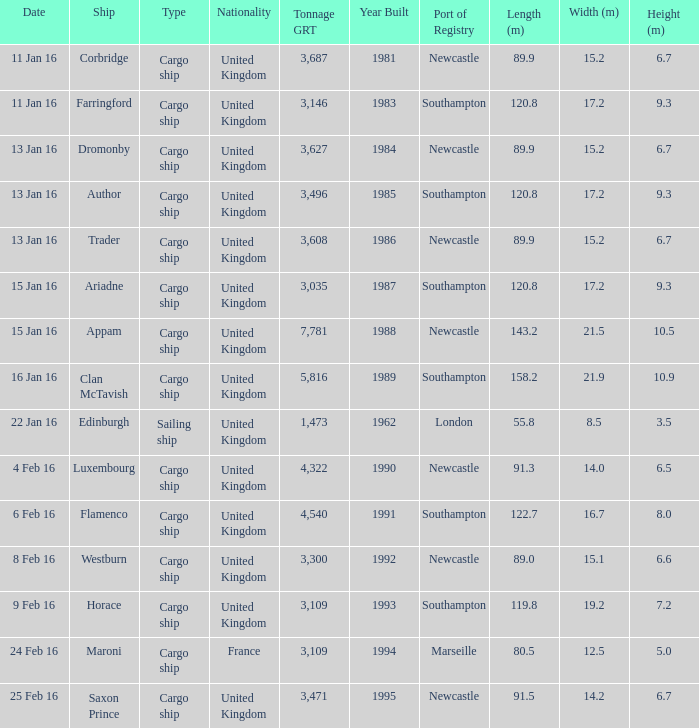Give me the full table as a dictionary. {'header': ['Date', 'Ship', 'Type', 'Nationality', 'Tonnage GRT', 'Year Built', 'Port of Registry', 'Length (m)', 'Width (m)', 'Height (m)'], 'rows': [['11 Jan 16', 'Corbridge', 'Cargo ship', 'United Kingdom', '3,687', '1981', 'Newcastle', '89.9', '15.2', '6.7'], ['11 Jan 16', 'Farringford', 'Cargo ship', 'United Kingdom', '3,146', '1983', 'Southampton', '120.8', '17.2', '9.3'], ['13 Jan 16', 'Dromonby', 'Cargo ship', 'United Kingdom', '3,627', '1984', 'Newcastle', '89.9', '15.2', '6.7'], ['13 Jan 16', 'Author', 'Cargo ship', 'United Kingdom', '3,496', '1985', 'Southampton', '120.8', '17.2', '9.3'], ['13 Jan 16', 'Trader', 'Cargo ship', 'United Kingdom', '3,608', '1986', 'Newcastle', '89.9', '15.2', '6.7'], ['15 Jan 16', 'Ariadne', 'Cargo ship', 'United Kingdom', '3,035', '1987', 'Southampton', '120.8', '17.2', '9.3'], ['15 Jan 16', 'Appam', 'Cargo ship', 'United Kingdom', '7,781', '1988', 'Newcastle', '143.2', '21.5', '10.5'], ['16 Jan 16', 'Clan McTavish', 'Cargo ship', 'United Kingdom', '5,816', '1989', 'Southampton', '158.2', '21.9', '10.9'], ['22 Jan 16', 'Edinburgh', 'Sailing ship', 'United Kingdom', '1,473', '1962', 'London', '55.8', '8.5', '3.5'], ['4 Feb 16', 'Luxembourg', 'Cargo ship', 'United Kingdom', '4,322', '1990', 'Newcastle', '91.3', '14.0', '6.5'], ['6 Feb 16', 'Flamenco', 'Cargo ship', 'United Kingdom', '4,540', '1991', 'Southampton', '122.7', '16.7', '8.0'], ['8 Feb 16', 'Westburn', 'Cargo ship', 'United Kingdom', '3,300', '1992', 'Newcastle', '89.0', '15.1', '6.6'], ['9 Feb 16', 'Horace', 'Cargo ship', 'United Kingdom', '3,109', '1993', 'Southampton', '119.8', '19.2', '7.2'], ['24 Feb 16', 'Maroni', 'Cargo ship', 'France', '3,109', '1994', 'Marseille', '80.5', '12.5', '5.0'], ['25 Feb 16', 'Saxon Prince', 'Cargo ship', 'United Kingdom', '3,471', '1995', 'Newcastle', '91.5', '14.2', '6.7']]} What is the tonnage grt of the ship author? 3496.0. 